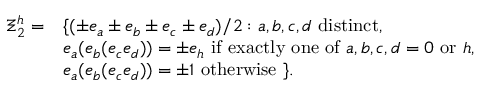Convert formula to latex. <formula><loc_0><loc_0><loc_500><loc_500>\begin{array} { c l } { { \Xi _ { 2 } ^ { h } = } } & { { \{ ( \pm e _ { a } \pm e _ { b } \pm e _ { c } \pm e _ { d } ) / 2 \colon a , b , c , d d i s t i n c t , } } & { { e _ { a } ( e _ { b } ( e _ { c } e _ { d } ) ) = \pm e _ { h } i f e x a c t l y o n e o f a , b , c , d = 0 o r h , } } & { { e _ { a } ( e _ { b } ( e _ { c } e _ { d } ) ) = \pm 1 o t h e r w i s e \} . } } \end{array}</formula> 